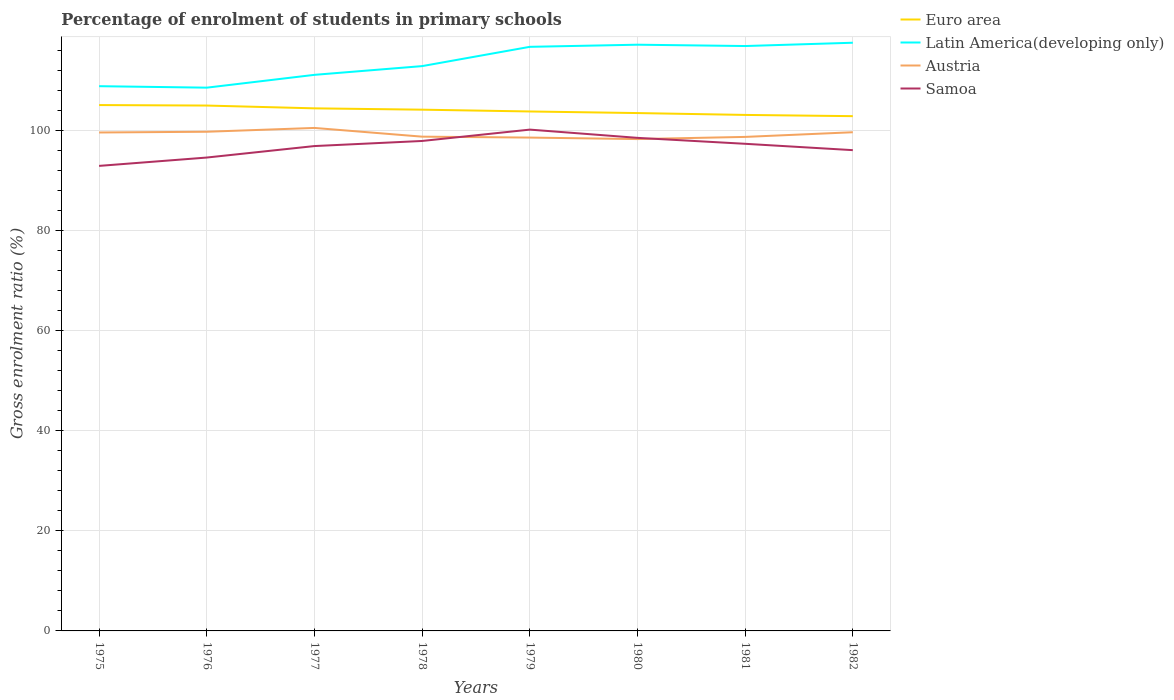Across all years, what is the maximum percentage of students enrolled in primary schools in Samoa?
Your answer should be compact. 92.93. In which year was the percentage of students enrolled in primary schools in Samoa maximum?
Ensure brevity in your answer.  1975. What is the total percentage of students enrolled in primary schools in Austria in the graph?
Ensure brevity in your answer.  0.98. What is the difference between the highest and the second highest percentage of students enrolled in primary schools in Latin America(developing only)?
Give a very brief answer. 8.98. Is the percentage of students enrolled in primary schools in Euro area strictly greater than the percentage of students enrolled in primary schools in Latin America(developing only) over the years?
Keep it short and to the point. Yes. How many lines are there?
Make the answer very short. 4. How many years are there in the graph?
Make the answer very short. 8. Does the graph contain any zero values?
Your response must be concise. No. How many legend labels are there?
Give a very brief answer. 4. How are the legend labels stacked?
Provide a short and direct response. Vertical. What is the title of the graph?
Ensure brevity in your answer.  Percentage of enrolment of students in primary schools. Does "Zimbabwe" appear as one of the legend labels in the graph?
Ensure brevity in your answer.  No. What is the label or title of the Y-axis?
Give a very brief answer. Gross enrolment ratio (%). What is the Gross enrolment ratio (%) in Euro area in 1975?
Provide a short and direct response. 105.08. What is the Gross enrolment ratio (%) of Latin America(developing only) in 1975?
Keep it short and to the point. 108.86. What is the Gross enrolment ratio (%) in Austria in 1975?
Provide a short and direct response. 99.6. What is the Gross enrolment ratio (%) of Samoa in 1975?
Provide a short and direct response. 92.93. What is the Gross enrolment ratio (%) of Euro area in 1976?
Your answer should be compact. 104.99. What is the Gross enrolment ratio (%) in Latin America(developing only) in 1976?
Provide a short and direct response. 108.56. What is the Gross enrolment ratio (%) of Austria in 1976?
Your response must be concise. 99.75. What is the Gross enrolment ratio (%) in Samoa in 1976?
Provide a short and direct response. 94.6. What is the Gross enrolment ratio (%) in Euro area in 1977?
Provide a short and direct response. 104.43. What is the Gross enrolment ratio (%) of Latin America(developing only) in 1977?
Offer a terse response. 111.12. What is the Gross enrolment ratio (%) of Austria in 1977?
Your response must be concise. 100.51. What is the Gross enrolment ratio (%) of Samoa in 1977?
Make the answer very short. 96.89. What is the Gross enrolment ratio (%) of Euro area in 1978?
Offer a very short reply. 104.16. What is the Gross enrolment ratio (%) of Latin America(developing only) in 1978?
Your response must be concise. 112.87. What is the Gross enrolment ratio (%) of Austria in 1978?
Offer a very short reply. 98.77. What is the Gross enrolment ratio (%) in Samoa in 1978?
Ensure brevity in your answer.  97.91. What is the Gross enrolment ratio (%) in Euro area in 1979?
Make the answer very short. 103.8. What is the Gross enrolment ratio (%) in Latin America(developing only) in 1979?
Give a very brief answer. 116.72. What is the Gross enrolment ratio (%) in Austria in 1979?
Your response must be concise. 98.59. What is the Gross enrolment ratio (%) in Samoa in 1979?
Offer a terse response. 100.18. What is the Gross enrolment ratio (%) in Euro area in 1980?
Your answer should be very brief. 103.49. What is the Gross enrolment ratio (%) of Latin America(developing only) in 1980?
Your answer should be very brief. 117.15. What is the Gross enrolment ratio (%) of Austria in 1980?
Your answer should be very brief. 98.29. What is the Gross enrolment ratio (%) in Samoa in 1980?
Provide a short and direct response. 98.53. What is the Gross enrolment ratio (%) in Euro area in 1981?
Your response must be concise. 103.12. What is the Gross enrolment ratio (%) of Latin America(developing only) in 1981?
Provide a succinct answer. 116.88. What is the Gross enrolment ratio (%) of Austria in 1981?
Ensure brevity in your answer.  98.72. What is the Gross enrolment ratio (%) in Samoa in 1981?
Make the answer very short. 97.34. What is the Gross enrolment ratio (%) in Euro area in 1982?
Keep it short and to the point. 102.87. What is the Gross enrolment ratio (%) of Latin America(developing only) in 1982?
Give a very brief answer. 117.54. What is the Gross enrolment ratio (%) of Austria in 1982?
Your answer should be very brief. 99.66. What is the Gross enrolment ratio (%) in Samoa in 1982?
Your response must be concise. 96.07. Across all years, what is the maximum Gross enrolment ratio (%) of Euro area?
Provide a succinct answer. 105.08. Across all years, what is the maximum Gross enrolment ratio (%) of Latin America(developing only)?
Provide a succinct answer. 117.54. Across all years, what is the maximum Gross enrolment ratio (%) of Austria?
Make the answer very short. 100.51. Across all years, what is the maximum Gross enrolment ratio (%) in Samoa?
Keep it short and to the point. 100.18. Across all years, what is the minimum Gross enrolment ratio (%) in Euro area?
Provide a succinct answer. 102.87. Across all years, what is the minimum Gross enrolment ratio (%) of Latin America(developing only)?
Keep it short and to the point. 108.56. Across all years, what is the minimum Gross enrolment ratio (%) of Austria?
Offer a terse response. 98.29. Across all years, what is the minimum Gross enrolment ratio (%) of Samoa?
Your response must be concise. 92.93. What is the total Gross enrolment ratio (%) of Euro area in the graph?
Your answer should be very brief. 831.93. What is the total Gross enrolment ratio (%) of Latin America(developing only) in the graph?
Give a very brief answer. 909.7. What is the total Gross enrolment ratio (%) in Austria in the graph?
Your answer should be very brief. 793.89. What is the total Gross enrolment ratio (%) in Samoa in the graph?
Your response must be concise. 774.46. What is the difference between the Gross enrolment ratio (%) in Euro area in 1975 and that in 1976?
Give a very brief answer. 0.1. What is the difference between the Gross enrolment ratio (%) in Latin America(developing only) in 1975 and that in 1976?
Provide a short and direct response. 0.29. What is the difference between the Gross enrolment ratio (%) in Austria in 1975 and that in 1976?
Your response must be concise. -0.15. What is the difference between the Gross enrolment ratio (%) in Samoa in 1975 and that in 1976?
Offer a terse response. -1.67. What is the difference between the Gross enrolment ratio (%) in Euro area in 1975 and that in 1977?
Make the answer very short. 0.66. What is the difference between the Gross enrolment ratio (%) of Latin America(developing only) in 1975 and that in 1977?
Your answer should be compact. -2.27. What is the difference between the Gross enrolment ratio (%) in Austria in 1975 and that in 1977?
Provide a succinct answer. -0.91. What is the difference between the Gross enrolment ratio (%) in Samoa in 1975 and that in 1977?
Keep it short and to the point. -3.96. What is the difference between the Gross enrolment ratio (%) of Euro area in 1975 and that in 1978?
Offer a terse response. 0.92. What is the difference between the Gross enrolment ratio (%) in Latin America(developing only) in 1975 and that in 1978?
Offer a terse response. -4.01. What is the difference between the Gross enrolment ratio (%) in Austria in 1975 and that in 1978?
Your response must be concise. 0.83. What is the difference between the Gross enrolment ratio (%) in Samoa in 1975 and that in 1978?
Make the answer very short. -4.98. What is the difference between the Gross enrolment ratio (%) of Euro area in 1975 and that in 1979?
Give a very brief answer. 1.28. What is the difference between the Gross enrolment ratio (%) of Latin America(developing only) in 1975 and that in 1979?
Make the answer very short. -7.86. What is the difference between the Gross enrolment ratio (%) in Austria in 1975 and that in 1979?
Your response must be concise. 1.02. What is the difference between the Gross enrolment ratio (%) of Samoa in 1975 and that in 1979?
Provide a short and direct response. -7.25. What is the difference between the Gross enrolment ratio (%) of Euro area in 1975 and that in 1980?
Offer a very short reply. 1.6. What is the difference between the Gross enrolment ratio (%) in Latin America(developing only) in 1975 and that in 1980?
Ensure brevity in your answer.  -8.29. What is the difference between the Gross enrolment ratio (%) of Austria in 1975 and that in 1980?
Ensure brevity in your answer.  1.32. What is the difference between the Gross enrolment ratio (%) in Samoa in 1975 and that in 1980?
Ensure brevity in your answer.  -5.6. What is the difference between the Gross enrolment ratio (%) of Euro area in 1975 and that in 1981?
Provide a short and direct response. 1.97. What is the difference between the Gross enrolment ratio (%) in Latin America(developing only) in 1975 and that in 1981?
Make the answer very short. -8.02. What is the difference between the Gross enrolment ratio (%) of Austria in 1975 and that in 1981?
Provide a succinct answer. 0.88. What is the difference between the Gross enrolment ratio (%) in Samoa in 1975 and that in 1981?
Your answer should be compact. -4.42. What is the difference between the Gross enrolment ratio (%) of Euro area in 1975 and that in 1982?
Provide a succinct answer. 2.22. What is the difference between the Gross enrolment ratio (%) in Latin America(developing only) in 1975 and that in 1982?
Ensure brevity in your answer.  -8.68. What is the difference between the Gross enrolment ratio (%) in Austria in 1975 and that in 1982?
Your answer should be very brief. -0.05. What is the difference between the Gross enrolment ratio (%) of Samoa in 1975 and that in 1982?
Your response must be concise. -3.15. What is the difference between the Gross enrolment ratio (%) of Euro area in 1976 and that in 1977?
Make the answer very short. 0.56. What is the difference between the Gross enrolment ratio (%) of Latin America(developing only) in 1976 and that in 1977?
Provide a succinct answer. -2.56. What is the difference between the Gross enrolment ratio (%) of Austria in 1976 and that in 1977?
Offer a terse response. -0.76. What is the difference between the Gross enrolment ratio (%) in Samoa in 1976 and that in 1977?
Give a very brief answer. -2.29. What is the difference between the Gross enrolment ratio (%) in Euro area in 1976 and that in 1978?
Ensure brevity in your answer.  0.82. What is the difference between the Gross enrolment ratio (%) of Latin America(developing only) in 1976 and that in 1978?
Provide a short and direct response. -4.31. What is the difference between the Gross enrolment ratio (%) in Austria in 1976 and that in 1978?
Provide a succinct answer. 0.98. What is the difference between the Gross enrolment ratio (%) of Samoa in 1976 and that in 1978?
Your response must be concise. -3.31. What is the difference between the Gross enrolment ratio (%) in Euro area in 1976 and that in 1979?
Provide a short and direct response. 1.18. What is the difference between the Gross enrolment ratio (%) of Latin America(developing only) in 1976 and that in 1979?
Keep it short and to the point. -8.16. What is the difference between the Gross enrolment ratio (%) of Austria in 1976 and that in 1979?
Ensure brevity in your answer.  1.16. What is the difference between the Gross enrolment ratio (%) in Samoa in 1976 and that in 1979?
Provide a succinct answer. -5.58. What is the difference between the Gross enrolment ratio (%) of Euro area in 1976 and that in 1980?
Your response must be concise. 1.5. What is the difference between the Gross enrolment ratio (%) of Latin America(developing only) in 1976 and that in 1980?
Keep it short and to the point. -8.58. What is the difference between the Gross enrolment ratio (%) in Austria in 1976 and that in 1980?
Give a very brief answer. 1.46. What is the difference between the Gross enrolment ratio (%) in Samoa in 1976 and that in 1980?
Ensure brevity in your answer.  -3.94. What is the difference between the Gross enrolment ratio (%) in Euro area in 1976 and that in 1981?
Your answer should be compact. 1.87. What is the difference between the Gross enrolment ratio (%) of Latin America(developing only) in 1976 and that in 1981?
Offer a terse response. -8.32. What is the difference between the Gross enrolment ratio (%) of Austria in 1976 and that in 1981?
Keep it short and to the point. 1.03. What is the difference between the Gross enrolment ratio (%) of Samoa in 1976 and that in 1981?
Offer a terse response. -2.75. What is the difference between the Gross enrolment ratio (%) in Euro area in 1976 and that in 1982?
Your answer should be very brief. 2.12. What is the difference between the Gross enrolment ratio (%) in Latin America(developing only) in 1976 and that in 1982?
Offer a very short reply. -8.98. What is the difference between the Gross enrolment ratio (%) of Austria in 1976 and that in 1982?
Offer a very short reply. 0.1. What is the difference between the Gross enrolment ratio (%) of Samoa in 1976 and that in 1982?
Your answer should be very brief. -1.48. What is the difference between the Gross enrolment ratio (%) of Euro area in 1977 and that in 1978?
Make the answer very short. 0.27. What is the difference between the Gross enrolment ratio (%) of Latin America(developing only) in 1977 and that in 1978?
Your response must be concise. -1.75. What is the difference between the Gross enrolment ratio (%) of Austria in 1977 and that in 1978?
Provide a short and direct response. 1.74. What is the difference between the Gross enrolment ratio (%) in Samoa in 1977 and that in 1978?
Ensure brevity in your answer.  -1.02. What is the difference between the Gross enrolment ratio (%) of Euro area in 1977 and that in 1979?
Provide a succinct answer. 0.62. What is the difference between the Gross enrolment ratio (%) of Latin America(developing only) in 1977 and that in 1979?
Your response must be concise. -5.6. What is the difference between the Gross enrolment ratio (%) in Austria in 1977 and that in 1979?
Your answer should be compact. 1.93. What is the difference between the Gross enrolment ratio (%) of Samoa in 1977 and that in 1979?
Your response must be concise. -3.29. What is the difference between the Gross enrolment ratio (%) of Euro area in 1977 and that in 1980?
Your response must be concise. 0.94. What is the difference between the Gross enrolment ratio (%) of Latin America(developing only) in 1977 and that in 1980?
Provide a short and direct response. -6.02. What is the difference between the Gross enrolment ratio (%) in Austria in 1977 and that in 1980?
Keep it short and to the point. 2.23. What is the difference between the Gross enrolment ratio (%) of Samoa in 1977 and that in 1980?
Ensure brevity in your answer.  -1.64. What is the difference between the Gross enrolment ratio (%) in Euro area in 1977 and that in 1981?
Your response must be concise. 1.31. What is the difference between the Gross enrolment ratio (%) of Latin America(developing only) in 1977 and that in 1981?
Offer a very short reply. -5.76. What is the difference between the Gross enrolment ratio (%) of Austria in 1977 and that in 1981?
Keep it short and to the point. 1.79. What is the difference between the Gross enrolment ratio (%) in Samoa in 1977 and that in 1981?
Offer a very short reply. -0.45. What is the difference between the Gross enrolment ratio (%) of Euro area in 1977 and that in 1982?
Your answer should be compact. 1.56. What is the difference between the Gross enrolment ratio (%) in Latin America(developing only) in 1977 and that in 1982?
Your answer should be compact. -6.42. What is the difference between the Gross enrolment ratio (%) in Austria in 1977 and that in 1982?
Your answer should be very brief. 0.86. What is the difference between the Gross enrolment ratio (%) in Samoa in 1977 and that in 1982?
Give a very brief answer. 0.82. What is the difference between the Gross enrolment ratio (%) of Euro area in 1978 and that in 1979?
Provide a succinct answer. 0.36. What is the difference between the Gross enrolment ratio (%) of Latin America(developing only) in 1978 and that in 1979?
Keep it short and to the point. -3.85. What is the difference between the Gross enrolment ratio (%) in Austria in 1978 and that in 1979?
Make the answer very short. 0.18. What is the difference between the Gross enrolment ratio (%) of Samoa in 1978 and that in 1979?
Ensure brevity in your answer.  -2.27. What is the difference between the Gross enrolment ratio (%) of Euro area in 1978 and that in 1980?
Your response must be concise. 0.68. What is the difference between the Gross enrolment ratio (%) in Latin America(developing only) in 1978 and that in 1980?
Provide a succinct answer. -4.28. What is the difference between the Gross enrolment ratio (%) of Austria in 1978 and that in 1980?
Offer a terse response. 0.48. What is the difference between the Gross enrolment ratio (%) in Samoa in 1978 and that in 1980?
Your response must be concise. -0.62. What is the difference between the Gross enrolment ratio (%) in Euro area in 1978 and that in 1981?
Make the answer very short. 1.05. What is the difference between the Gross enrolment ratio (%) of Latin America(developing only) in 1978 and that in 1981?
Ensure brevity in your answer.  -4.01. What is the difference between the Gross enrolment ratio (%) of Austria in 1978 and that in 1981?
Provide a succinct answer. 0.05. What is the difference between the Gross enrolment ratio (%) of Samoa in 1978 and that in 1981?
Give a very brief answer. 0.57. What is the difference between the Gross enrolment ratio (%) of Euro area in 1978 and that in 1982?
Make the answer very short. 1.3. What is the difference between the Gross enrolment ratio (%) in Latin America(developing only) in 1978 and that in 1982?
Give a very brief answer. -4.67. What is the difference between the Gross enrolment ratio (%) in Austria in 1978 and that in 1982?
Offer a very short reply. -0.88. What is the difference between the Gross enrolment ratio (%) in Samoa in 1978 and that in 1982?
Keep it short and to the point. 1.84. What is the difference between the Gross enrolment ratio (%) of Euro area in 1979 and that in 1980?
Your response must be concise. 0.32. What is the difference between the Gross enrolment ratio (%) of Latin America(developing only) in 1979 and that in 1980?
Provide a succinct answer. -0.42. What is the difference between the Gross enrolment ratio (%) of Austria in 1979 and that in 1980?
Offer a terse response. 0.3. What is the difference between the Gross enrolment ratio (%) in Samoa in 1979 and that in 1980?
Make the answer very short. 1.65. What is the difference between the Gross enrolment ratio (%) of Euro area in 1979 and that in 1981?
Offer a terse response. 0.69. What is the difference between the Gross enrolment ratio (%) of Latin America(developing only) in 1979 and that in 1981?
Offer a terse response. -0.16. What is the difference between the Gross enrolment ratio (%) in Austria in 1979 and that in 1981?
Keep it short and to the point. -0.13. What is the difference between the Gross enrolment ratio (%) in Samoa in 1979 and that in 1981?
Make the answer very short. 2.83. What is the difference between the Gross enrolment ratio (%) of Euro area in 1979 and that in 1982?
Provide a short and direct response. 0.94. What is the difference between the Gross enrolment ratio (%) of Latin America(developing only) in 1979 and that in 1982?
Offer a very short reply. -0.82. What is the difference between the Gross enrolment ratio (%) of Austria in 1979 and that in 1982?
Ensure brevity in your answer.  -1.07. What is the difference between the Gross enrolment ratio (%) of Samoa in 1979 and that in 1982?
Your answer should be very brief. 4.1. What is the difference between the Gross enrolment ratio (%) of Euro area in 1980 and that in 1981?
Make the answer very short. 0.37. What is the difference between the Gross enrolment ratio (%) in Latin America(developing only) in 1980 and that in 1981?
Provide a short and direct response. 0.27. What is the difference between the Gross enrolment ratio (%) of Austria in 1980 and that in 1981?
Your answer should be very brief. -0.43. What is the difference between the Gross enrolment ratio (%) of Samoa in 1980 and that in 1981?
Provide a succinct answer. 1.19. What is the difference between the Gross enrolment ratio (%) in Euro area in 1980 and that in 1982?
Make the answer very short. 0.62. What is the difference between the Gross enrolment ratio (%) of Latin America(developing only) in 1980 and that in 1982?
Provide a succinct answer. -0.39. What is the difference between the Gross enrolment ratio (%) in Austria in 1980 and that in 1982?
Offer a very short reply. -1.37. What is the difference between the Gross enrolment ratio (%) of Samoa in 1980 and that in 1982?
Offer a terse response. 2.46. What is the difference between the Gross enrolment ratio (%) of Euro area in 1981 and that in 1982?
Ensure brevity in your answer.  0.25. What is the difference between the Gross enrolment ratio (%) of Latin America(developing only) in 1981 and that in 1982?
Make the answer very short. -0.66. What is the difference between the Gross enrolment ratio (%) of Austria in 1981 and that in 1982?
Provide a short and direct response. -0.93. What is the difference between the Gross enrolment ratio (%) in Samoa in 1981 and that in 1982?
Your answer should be compact. 1.27. What is the difference between the Gross enrolment ratio (%) of Euro area in 1975 and the Gross enrolment ratio (%) of Latin America(developing only) in 1976?
Ensure brevity in your answer.  -3.48. What is the difference between the Gross enrolment ratio (%) of Euro area in 1975 and the Gross enrolment ratio (%) of Austria in 1976?
Your response must be concise. 5.33. What is the difference between the Gross enrolment ratio (%) of Euro area in 1975 and the Gross enrolment ratio (%) of Samoa in 1976?
Your answer should be compact. 10.49. What is the difference between the Gross enrolment ratio (%) in Latin America(developing only) in 1975 and the Gross enrolment ratio (%) in Austria in 1976?
Offer a terse response. 9.1. What is the difference between the Gross enrolment ratio (%) of Latin America(developing only) in 1975 and the Gross enrolment ratio (%) of Samoa in 1976?
Ensure brevity in your answer.  14.26. What is the difference between the Gross enrolment ratio (%) in Austria in 1975 and the Gross enrolment ratio (%) in Samoa in 1976?
Your response must be concise. 5.01. What is the difference between the Gross enrolment ratio (%) of Euro area in 1975 and the Gross enrolment ratio (%) of Latin America(developing only) in 1977?
Your answer should be very brief. -6.04. What is the difference between the Gross enrolment ratio (%) of Euro area in 1975 and the Gross enrolment ratio (%) of Austria in 1977?
Provide a short and direct response. 4.57. What is the difference between the Gross enrolment ratio (%) of Euro area in 1975 and the Gross enrolment ratio (%) of Samoa in 1977?
Your answer should be very brief. 8.19. What is the difference between the Gross enrolment ratio (%) of Latin America(developing only) in 1975 and the Gross enrolment ratio (%) of Austria in 1977?
Ensure brevity in your answer.  8.34. What is the difference between the Gross enrolment ratio (%) of Latin America(developing only) in 1975 and the Gross enrolment ratio (%) of Samoa in 1977?
Your answer should be very brief. 11.97. What is the difference between the Gross enrolment ratio (%) of Austria in 1975 and the Gross enrolment ratio (%) of Samoa in 1977?
Your answer should be compact. 2.71. What is the difference between the Gross enrolment ratio (%) in Euro area in 1975 and the Gross enrolment ratio (%) in Latin America(developing only) in 1978?
Provide a succinct answer. -7.78. What is the difference between the Gross enrolment ratio (%) of Euro area in 1975 and the Gross enrolment ratio (%) of Austria in 1978?
Your answer should be very brief. 6.31. What is the difference between the Gross enrolment ratio (%) of Euro area in 1975 and the Gross enrolment ratio (%) of Samoa in 1978?
Ensure brevity in your answer.  7.17. What is the difference between the Gross enrolment ratio (%) of Latin America(developing only) in 1975 and the Gross enrolment ratio (%) of Austria in 1978?
Offer a very short reply. 10.09. What is the difference between the Gross enrolment ratio (%) in Latin America(developing only) in 1975 and the Gross enrolment ratio (%) in Samoa in 1978?
Offer a terse response. 10.95. What is the difference between the Gross enrolment ratio (%) in Austria in 1975 and the Gross enrolment ratio (%) in Samoa in 1978?
Your response must be concise. 1.69. What is the difference between the Gross enrolment ratio (%) of Euro area in 1975 and the Gross enrolment ratio (%) of Latin America(developing only) in 1979?
Offer a terse response. -11.64. What is the difference between the Gross enrolment ratio (%) in Euro area in 1975 and the Gross enrolment ratio (%) in Austria in 1979?
Your answer should be compact. 6.5. What is the difference between the Gross enrolment ratio (%) of Euro area in 1975 and the Gross enrolment ratio (%) of Samoa in 1979?
Give a very brief answer. 4.91. What is the difference between the Gross enrolment ratio (%) in Latin America(developing only) in 1975 and the Gross enrolment ratio (%) in Austria in 1979?
Ensure brevity in your answer.  10.27. What is the difference between the Gross enrolment ratio (%) in Latin America(developing only) in 1975 and the Gross enrolment ratio (%) in Samoa in 1979?
Give a very brief answer. 8.68. What is the difference between the Gross enrolment ratio (%) of Austria in 1975 and the Gross enrolment ratio (%) of Samoa in 1979?
Give a very brief answer. -0.57. What is the difference between the Gross enrolment ratio (%) of Euro area in 1975 and the Gross enrolment ratio (%) of Latin America(developing only) in 1980?
Offer a very short reply. -12.06. What is the difference between the Gross enrolment ratio (%) of Euro area in 1975 and the Gross enrolment ratio (%) of Austria in 1980?
Your answer should be very brief. 6.8. What is the difference between the Gross enrolment ratio (%) of Euro area in 1975 and the Gross enrolment ratio (%) of Samoa in 1980?
Offer a terse response. 6.55. What is the difference between the Gross enrolment ratio (%) of Latin America(developing only) in 1975 and the Gross enrolment ratio (%) of Austria in 1980?
Your answer should be very brief. 10.57. What is the difference between the Gross enrolment ratio (%) in Latin America(developing only) in 1975 and the Gross enrolment ratio (%) in Samoa in 1980?
Provide a short and direct response. 10.32. What is the difference between the Gross enrolment ratio (%) of Austria in 1975 and the Gross enrolment ratio (%) of Samoa in 1980?
Provide a succinct answer. 1.07. What is the difference between the Gross enrolment ratio (%) in Euro area in 1975 and the Gross enrolment ratio (%) in Latin America(developing only) in 1981?
Offer a very short reply. -11.8. What is the difference between the Gross enrolment ratio (%) in Euro area in 1975 and the Gross enrolment ratio (%) in Austria in 1981?
Provide a succinct answer. 6.36. What is the difference between the Gross enrolment ratio (%) in Euro area in 1975 and the Gross enrolment ratio (%) in Samoa in 1981?
Your answer should be very brief. 7.74. What is the difference between the Gross enrolment ratio (%) of Latin America(developing only) in 1975 and the Gross enrolment ratio (%) of Austria in 1981?
Ensure brevity in your answer.  10.14. What is the difference between the Gross enrolment ratio (%) in Latin America(developing only) in 1975 and the Gross enrolment ratio (%) in Samoa in 1981?
Offer a terse response. 11.51. What is the difference between the Gross enrolment ratio (%) in Austria in 1975 and the Gross enrolment ratio (%) in Samoa in 1981?
Provide a succinct answer. 2.26. What is the difference between the Gross enrolment ratio (%) in Euro area in 1975 and the Gross enrolment ratio (%) in Latin America(developing only) in 1982?
Provide a short and direct response. -12.46. What is the difference between the Gross enrolment ratio (%) in Euro area in 1975 and the Gross enrolment ratio (%) in Austria in 1982?
Provide a short and direct response. 5.43. What is the difference between the Gross enrolment ratio (%) of Euro area in 1975 and the Gross enrolment ratio (%) of Samoa in 1982?
Offer a terse response. 9.01. What is the difference between the Gross enrolment ratio (%) of Latin America(developing only) in 1975 and the Gross enrolment ratio (%) of Austria in 1982?
Make the answer very short. 9.2. What is the difference between the Gross enrolment ratio (%) in Latin America(developing only) in 1975 and the Gross enrolment ratio (%) in Samoa in 1982?
Make the answer very short. 12.78. What is the difference between the Gross enrolment ratio (%) of Austria in 1975 and the Gross enrolment ratio (%) of Samoa in 1982?
Provide a short and direct response. 3.53. What is the difference between the Gross enrolment ratio (%) of Euro area in 1976 and the Gross enrolment ratio (%) of Latin America(developing only) in 1977?
Make the answer very short. -6.14. What is the difference between the Gross enrolment ratio (%) in Euro area in 1976 and the Gross enrolment ratio (%) in Austria in 1977?
Your answer should be compact. 4.47. What is the difference between the Gross enrolment ratio (%) of Euro area in 1976 and the Gross enrolment ratio (%) of Samoa in 1977?
Make the answer very short. 8.1. What is the difference between the Gross enrolment ratio (%) of Latin America(developing only) in 1976 and the Gross enrolment ratio (%) of Austria in 1977?
Ensure brevity in your answer.  8.05. What is the difference between the Gross enrolment ratio (%) in Latin America(developing only) in 1976 and the Gross enrolment ratio (%) in Samoa in 1977?
Your answer should be very brief. 11.67. What is the difference between the Gross enrolment ratio (%) in Austria in 1976 and the Gross enrolment ratio (%) in Samoa in 1977?
Give a very brief answer. 2.86. What is the difference between the Gross enrolment ratio (%) in Euro area in 1976 and the Gross enrolment ratio (%) in Latin America(developing only) in 1978?
Give a very brief answer. -7.88. What is the difference between the Gross enrolment ratio (%) in Euro area in 1976 and the Gross enrolment ratio (%) in Austria in 1978?
Provide a succinct answer. 6.22. What is the difference between the Gross enrolment ratio (%) of Euro area in 1976 and the Gross enrolment ratio (%) of Samoa in 1978?
Keep it short and to the point. 7.08. What is the difference between the Gross enrolment ratio (%) in Latin America(developing only) in 1976 and the Gross enrolment ratio (%) in Austria in 1978?
Provide a short and direct response. 9.79. What is the difference between the Gross enrolment ratio (%) of Latin America(developing only) in 1976 and the Gross enrolment ratio (%) of Samoa in 1978?
Provide a succinct answer. 10.65. What is the difference between the Gross enrolment ratio (%) in Austria in 1976 and the Gross enrolment ratio (%) in Samoa in 1978?
Provide a succinct answer. 1.84. What is the difference between the Gross enrolment ratio (%) in Euro area in 1976 and the Gross enrolment ratio (%) in Latin America(developing only) in 1979?
Your answer should be compact. -11.73. What is the difference between the Gross enrolment ratio (%) of Euro area in 1976 and the Gross enrolment ratio (%) of Austria in 1979?
Your answer should be compact. 6.4. What is the difference between the Gross enrolment ratio (%) of Euro area in 1976 and the Gross enrolment ratio (%) of Samoa in 1979?
Offer a very short reply. 4.81. What is the difference between the Gross enrolment ratio (%) of Latin America(developing only) in 1976 and the Gross enrolment ratio (%) of Austria in 1979?
Provide a succinct answer. 9.97. What is the difference between the Gross enrolment ratio (%) in Latin America(developing only) in 1976 and the Gross enrolment ratio (%) in Samoa in 1979?
Ensure brevity in your answer.  8.38. What is the difference between the Gross enrolment ratio (%) in Austria in 1976 and the Gross enrolment ratio (%) in Samoa in 1979?
Keep it short and to the point. -0.43. What is the difference between the Gross enrolment ratio (%) in Euro area in 1976 and the Gross enrolment ratio (%) in Latin America(developing only) in 1980?
Keep it short and to the point. -12.16. What is the difference between the Gross enrolment ratio (%) in Euro area in 1976 and the Gross enrolment ratio (%) in Austria in 1980?
Provide a short and direct response. 6.7. What is the difference between the Gross enrolment ratio (%) of Euro area in 1976 and the Gross enrolment ratio (%) of Samoa in 1980?
Keep it short and to the point. 6.46. What is the difference between the Gross enrolment ratio (%) in Latin America(developing only) in 1976 and the Gross enrolment ratio (%) in Austria in 1980?
Give a very brief answer. 10.28. What is the difference between the Gross enrolment ratio (%) in Latin America(developing only) in 1976 and the Gross enrolment ratio (%) in Samoa in 1980?
Give a very brief answer. 10.03. What is the difference between the Gross enrolment ratio (%) in Austria in 1976 and the Gross enrolment ratio (%) in Samoa in 1980?
Offer a terse response. 1.22. What is the difference between the Gross enrolment ratio (%) in Euro area in 1976 and the Gross enrolment ratio (%) in Latin America(developing only) in 1981?
Make the answer very short. -11.89. What is the difference between the Gross enrolment ratio (%) in Euro area in 1976 and the Gross enrolment ratio (%) in Austria in 1981?
Offer a very short reply. 6.27. What is the difference between the Gross enrolment ratio (%) of Euro area in 1976 and the Gross enrolment ratio (%) of Samoa in 1981?
Provide a short and direct response. 7.64. What is the difference between the Gross enrolment ratio (%) in Latin America(developing only) in 1976 and the Gross enrolment ratio (%) in Austria in 1981?
Ensure brevity in your answer.  9.84. What is the difference between the Gross enrolment ratio (%) in Latin America(developing only) in 1976 and the Gross enrolment ratio (%) in Samoa in 1981?
Give a very brief answer. 11.22. What is the difference between the Gross enrolment ratio (%) of Austria in 1976 and the Gross enrolment ratio (%) of Samoa in 1981?
Ensure brevity in your answer.  2.41. What is the difference between the Gross enrolment ratio (%) of Euro area in 1976 and the Gross enrolment ratio (%) of Latin America(developing only) in 1982?
Ensure brevity in your answer.  -12.55. What is the difference between the Gross enrolment ratio (%) in Euro area in 1976 and the Gross enrolment ratio (%) in Austria in 1982?
Provide a short and direct response. 5.33. What is the difference between the Gross enrolment ratio (%) of Euro area in 1976 and the Gross enrolment ratio (%) of Samoa in 1982?
Ensure brevity in your answer.  8.91. What is the difference between the Gross enrolment ratio (%) in Latin America(developing only) in 1976 and the Gross enrolment ratio (%) in Austria in 1982?
Offer a terse response. 8.91. What is the difference between the Gross enrolment ratio (%) of Latin America(developing only) in 1976 and the Gross enrolment ratio (%) of Samoa in 1982?
Your answer should be very brief. 12.49. What is the difference between the Gross enrolment ratio (%) of Austria in 1976 and the Gross enrolment ratio (%) of Samoa in 1982?
Offer a terse response. 3.68. What is the difference between the Gross enrolment ratio (%) of Euro area in 1977 and the Gross enrolment ratio (%) of Latin America(developing only) in 1978?
Your response must be concise. -8.44. What is the difference between the Gross enrolment ratio (%) of Euro area in 1977 and the Gross enrolment ratio (%) of Austria in 1978?
Your answer should be compact. 5.66. What is the difference between the Gross enrolment ratio (%) in Euro area in 1977 and the Gross enrolment ratio (%) in Samoa in 1978?
Keep it short and to the point. 6.52. What is the difference between the Gross enrolment ratio (%) in Latin America(developing only) in 1977 and the Gross enrolment ratio (%) in Austria in 1978?
Keep it short and to the point. 12.35. What is the difference between the Gross enrolment ratio (%) in Latin America(developing only) in 1977 and the Gross enrolment ratio (%) in Samoa in 1978?
Give a very brief answer. 13.21. What is the difference between the Gross enrolment ratio (%) in Austria in 1977 and the Gross enrolment ratio (%) in Samoa in 1978?
Give a very brief answer. 2.6. What is the difference between the Gross enrolment ratio (%) in Euro area in 1977 and the Gross enrolment ratio (%) in Latin America(developing only) in 1979?
Ensure brevity in your answer.  -12.29. What is the difference between the Gross enrolment ratio (%) in Euro area in 1977 and the Gross enrolment ratio (%) in Austria in 1979?
Ensure brevity in your answer.  5.84. What is the difference between the Gross enrolment ratio (%) in Euro area in 1977 and the Gross enrolment ratio (%) in Samoa in 1979?
Your answer should be very brief. 4.25. What is the difference between the Gross enrolment ratio (%) in Latin America(developing only) in 1977 and the Gross enrolment ratio (%) in Austria in 1979?
Make the answer very short. 12.53. What is the difference between the Gross enrolment ratio (%) in Latin America(developing only) in 1977 and the Gross enrolment ratio (%) in Samoa in 1979?
Your response must be concise. 10.94. What is the difference between the Gross enrolment ratio (%) of Austria in 1977 and the Gross enrolment ratio (%) of Samoa in 1979?
Your answer should be compact. 0.34. What is the difference between the Gross enrolment ratio (%) of Euro area in 1977 and the Gross enrolment ratio (%) of Latin America(developing only) in 1980?
Provide a short and direct response. -12.72. What is the difference between the Gross enrolment ratio (%) in Euro area in 1977 and the Gross enrolment ratio (%) in Austria in 1980?
Make the answer very short. 6.14. What is the difference between the Gross enrolment ratio (%) of Euro area in 1977 and the Gross enrolment ratio (%) of Samoa in 1980?
Your answer should be very brief. 5.9. What is the difference between the Gross enrolment ratio (%) of Latin America(developing only) in 1977 and the Gross enrolment ratio (%) of Austria in 1980?
Your answer should be compact. 12.84. What is the difference between the Gross enrolment ratio (%) in Latin America(developing only) in 1977 and the Gross enrolment ratio (%) in Samoa in 1980?
Ensure brevity in your answer.  12.59. What is the difference between the Gross enrolment ratio (%) in Austria in 1977 and the Gross enrolment ratio (%) in Samoa in 1980?
Give a very brief answer. 1.98. What is the difference between the Gross enrolment ratio (%) in Euro area in 1977 and the Gross enrolment ratio (%) in Latin America(developing only) in 1981?
Give a very brief answer. -12.45. What is the difference between the Gross enrolment ratio (%) of Euro area in 1977 and the Gross enrolment ratio (%) of Austria in 1981?
Your answer should be very brief. 5.71. What is the difference between the Gross enrolment ratio (%) of Euro area in 1977 and the Gross enrolment ratio (%) of Samoa in 1981?
Keep it short and to the point. 7.08. What is the difference between the Gross enrolment ratio (%) of Latin America(developing only) in 1977 and the Gross enrolment ratio (%) of Austria in 1981?
Provide a succinct answer. 12.4. What is the difference between the Gross enrolment ratio (%) in Latin America(developing only) in 1977 and the Gross enrolment ratio (%) in Samoa in 1981?
Your answer should be compact. 13.78. What is the difference between the Gross enrolment ratio (%) in Austria in 1977 and the Gross enrolment ratio (%) in Samoa in 1981?
Ensure brevity in your answer.  3.17. What is the difference between the Gross enrolment ratio (%) of Euro area in 1977 and the Gross enrolment ratio (%) of Latin America(developing only) in 1982?
Ensure brevity in your answer.  -13.11. What is the difference between the Gross enrolment ratio (%) of Euro area in 1977 and the Gross enrolment ratio (%) of Austria in 1982?
Provide a succinct answer. 4.77. What is the difference between the Gross enrolment ratio (%) of Euro area in 1977 and the Gross enrolment ratio (%) of Samoa in 1982?
Provide a succinct answer. 8.35. What is the difference between the Gross enrolment ratio (%) in Latin America(developing only) in 1977 and the Gross enrolment ratio (%) in Austria in 1982?
Ensure brevity in your answer.  11.47. What is the difference between the Gross enrolment ratio (%) in Latin America(developing only) in 1977 and the Gross enrolment ratio (%) in Samoa in 1982?
Keep it short and to the point. 15.05. What is the difference between the Gross enrolment ratio (%) in Austria in 1977 and the Gross enrolment ratio (%) in Samoa in 1982?
Provide a succinct answer. 4.44. What is the difference between the Gross enrolment ratio (%) in Euro area in 1978 and the Gross enrolment ratio (%) in Latin America(developing only) in 1979?
Your answer should be very brief. -12.56. What is the difference between the Gross enrolment ratio (%) of Euro area in 1978 and the Gross enrolment ratio (%) of Austria in 1979?
Keep it short and to the point. 5.57. What is the difference between the Gross enrolment ratio (%) of Euro area in 1978 and the Gross enrolment ratio (%) of Samoa in 1979?
Your answer should be very brief. 3.98. What is the difference between the Gross enrolment ratio (%) in Latin America(developing only) in 1978 and the Gross enrolment ratio (%) in Austria in 1979?
Ensure brevity in your answer.  14.28. What is the difference between the Gross enrolment ratio (%) in Latin America(developing only) in 1978 and the Gross enrolment ratio (%) in Samoa in 1979?
Offer a very short reply. 12.69. What is the difference between the Gross enrolment ratio (%) in Austria in 1978 and the Gross enrolment ratio (%) in Samoa in 1979?
Provide a short and direct response. -1.41. What is the difference between the Gross enrolment ratio (%) in Euro area in 1978 and the Gross enrolment ratio (%) in Latin America(developing only) in 1980?
Make the answer very short. -12.98. What is the difference between the Gross enrolment ratio (%) of Euro area in 1978 and the Gross enrolment ratio (%) of Austria in 1980?
Offer a terse response. 5.88. What is the difference between the Gross enrolment ratio (%) of Euro area in 1978 and the Gross enrolment ratio (%) of Samoa in 1980?
Ensure brevity in your answer.  5.63. What is the difference between the Gross enrolment ratio (%) of Latin America(developing only) in 1978 and the Gross enrolment ratio (%) of Austria in 1980?
Ensure brevity in your answer.  14.58. What is the difference between the Gross enrolment ratio (%) in Latin America(developing only) in 1978 and the Gross enrolment ratio (%) in Samoa in 1980?
Your answer should be compact. 14.34. What is the difference between the Gross enrolment ratio (%) of Austria in 1978 and the Gross enrolment ratio (%) of Samoa in 1980?
Your answer should be compact. 0.24. What is the difference between the Gross enrolment ratio (%) in Euro area in 1978 and the Gross enrolment ratio (%) in Latin America(developing only) in 1981?
Ensure brevity in your answer.  -12.72. What is the difference between the Gross enrolment ratio (%) in Euro area in 1978 and the Gross enrolment ratio (%) in Austria in 1981?
Provide a short and direct response. 5.44. What is the difference between the Gross enrolment ratio (%) in Euro area in 1978 and the Gross enrolment ratio (%) in Samoa in 1981?
Offer a terse response. 6.82. What is the difference between the Gross enrolment ratio (%) in Latin America(developing only) in 1978 and the Gross enrolment ratio (%) in Austria in 1981?
Make the answer very short. 14.15. What is the difference between the Gross enrolment ratio (%) of Latin America(developing only) in 1978 and the Gross enrolment ratio (%) of Samoa in 1981?
Your answer should be compact. 15.52. What is the difference between the Gross enrolment ratio (%) of Austria in 1978 and the Gross enrolment ratio (%) of Samoa in 1981?
Offer a very short reply. 1.43. What is the difference between the Gross enrolment ratio (%) in Euro area in 1978 and the Gross enrolment ratio (%) in Latin America(developing only) in 1982?
Provide a short and direct response. -13.38. What is the difference between the Gross enrolment ratio (%) of Euro area in 1978 and the Gross enrolment ratio (%) of Austria in 1982?
Offer a very short reply. 4.51. What is the difference between the Gross enrolment ratio (%) in Euro area in 1978 and the Gross enrolment ratio (%) in Samoa in 1982?
Offer a very short reply. 8.09. What is the difference between the Gross enrolment ratio (%) in Latin America(developing only) in 1978 and the Gross enrolment ratio (%) in Austria in 1982?
Give a very brief answer. 13.21. What is the difference between the Gross enrolment ratio (%) of Latin America(developing only) in 1978 and the Gross enrolment ratio (%) of Samoa in 1982?
Offer a very short reply. 16.79. What is the difference between the Gross enrolment ratio (%) in Austria in 1978 and the Gross enrolment ratio (%) in Samoa in 1982?
Your answer should be very brief. 2.7. What is the difference between the Gross enrolment ratio (%) in Euro area in 1979 and the Gross enrolment ratio (%) in Latin America(developing only) in 1980?
Your answer should be compact. -13.34. What is the difference between the Gross enrolment ratio (%) of Euro area in 1979 and the Gross enrolment ratio (%) of Austria in 1980?
Provide a succinct answer. 5.52. What is the difference between the Gross enrolment ratio (%) of Euro area in 1979 and the Gross enrolment ratio (%) of Samoa in 1980?
Your response must be concise. 5.27. What is the difference between the Gross enrolment ratio (%) of Latin America(developing only) in 1979 and the Gross enrolment ratio (%) of Austria in 1980?
Offer a very short reply. 18.43. What is the difference between the Gross enrolment ratio (%) of Latin America(developing only) in 1979 and the Gross enrolment ratio (%) of Samoa in 1980?
Your response must be concise. 18.19. What is the difference between the Gross enrolment ratio (%) of Austria in 1979 and the Gross enrolment ratio (%) of Samoa in 1980?
Ensure brevity in your answer.  0.06. What is the difference between the Gross enrolment ratio (%) in Euro area in 1979 and the Gross enrolment ratio (%) in Latin America(developing only) in 1981?
Offer a very short reply. -13.08. What is the difference between the Gross enrolment ratio (%) in Euro area in 1979 and the Gross enrolment ratio (%) in Austria in 1981?
Offer a terse response. 5.08. What is the difference between the Gross enrolment ratio (%) in Euro area in 1979 and the Gross enrolment ratio (%) in Samoa in 1981?
Your response must be concise. 6.46. What is the difference between the Gross enrolment ratio (%) of Latin America(developing only) in 1979 and the Gross enrolment ratio (%) of Austria in 1981?
Your response must be concise. 18. What is the difference between the Gross enrolment ratio (%) of Latin America(developing only) in 1979 and the Gross enrolment ratio (%) of Samoa in 1981?
Give a very brief answer. 19.38. What is the difference between the Gross enrolment ratio (%) of Austria in 1979 and the Gross enrolment ratio (%) of Samoa in 1981?
Your answer should be very brief. 1.24. What is the difference between the Gross enrolment ratio (%) in Euro area in 1979 and the Gross enrolment ratio (%) in Latin America(developing only) in 1982?
Give a very brief answer. -13.74. What is the difference between the Gross enrolment ratio (%) of Euro area in 1979 and the Gross enrolment ratio (%) of Austria in 1982?
Offer a terse response. 4.15. What is the difference between the Gross enrolment ratio (%) in Euro area in 1979 and the Gross enrolment ratio (%) in Samoa in 1982?
Give a very brief answer. 7.73. What is the difference between the Gross enrolment ratio (%) of Latin America(developing only) in 1979 and the Gross enrolment ratio (%) of Austria in 1982?
Provide a succinct answer. 17.07. What is the difference between the Gross enrolment ratio (%) in Latin America(developing only) in 1979 and the Gross enrolment ratio (%) in Samoa in 1982?
Ensure brevity in your answer.  20.65. What is the difference between the Gross enrolment ratio (%) of Austria in 1979 and the Gross enrolment ratio (%) of Samoa in 1982?
Provide a short and direct response. 2.51. What is the difference between the Gross enrolment ratio (%) of Euro area in 1980 and the Gross enrolment ratio (%) of Latin America(developing only) in 1981?
Give a very brief answer. -13.39. What is the difference between the Gross enrolment ratio (%) in Euro area in 1980 and the Gross enrolment ratio (%) in Austria in 1981?
Offer a terse response. 4.76. What is the difference between the Gross enrolment ratio (%) of Euro area in 1980 and the Gross enrolment ratio (%) of Samoa in 1981?
Your answer should be very brief. 6.14. What is the difference between the Gross enrolment ratio (%) in Latin America(developing only) in 1980 and the Gross enrolment ratio (%) in Austria in 1981?
Make the answer very short. 18.43. What is the difference between the Gross enrolment ratio (%) in Latin America(developing only) in 1980 and the Gross enrolment ratio (%) in Samoa in 1981?
Your response must be concise. 19.8. What is the difference between the Gross enrolment ratio (%) of Austria in 1980 and the Gross enrolment ratio (%) of Samoa in 1981?
Your answer should be compact. 0.94. What is the difference between the Gross enrolment ratio (%) of Euro area in 1980 and the Gross enrolment ratio (%) of Latin America(developing only) in 1982?
Provide a succinct answer. -14.05. What is the difference between the Gross enrolment ratio (%) of Euro area in 1980 and the Gross enrolment ratio (%) of Austria in 1982?
Your answer should be very brief. 3.83. What is the difference between the Gross enrolment ratio (%) in Euro area in 1980 and the Gross enrolment ratio (%) in Samoa in 1982?
Provide a short and direct response. 7.41. What is the difference between the Gross enrolment ratio (%) of Latin America(developing only) in 1980 and the Gross enrolment ratio (%) of Austria in 1982?
Offer a terse response. 17.49. What is the difference between the Gross enrolment ratio (%) in Latin America(developing only) in 1980 and the Gross enrolment ratio (%) in Samoa in 1982?
Offer a very short reply. 21.07. What is the difference between the Gross enrolment ratio (%) of Austria in 1980 and the Gross enrolment ratio (%) of Samoa in 1982?
Provide a succinct answer. 2.21. What is the difference between the Gross enrolment ratio (%) of Euro area in 1981 and the Gross enrolment ratio (%) of Latin America(developing only) in 1982?
Your answer should be compact. -14.42. What is the difference between the Gross enrolment ratio (%) in Euro area in 1981 and the Gross enrolment ratio (%) in Austria in 1982?
Offer a very short reply. 3.46. What is the difference between the Gross enrolment ratio (%) of Euro area in 1981 and the Gross enrolment ratio (%) of Samoa in 1982?
Your response must be concise. 7.04. What is the difference between the Gross enrolment ratio (%) of Latin America(developing only) in 1981 and the Gross enrolment ratio (%) of Austria in 1982?
Ensure brevity in your answer.  17.23. What is the difference between the Gross enrolment ratio (%) in Latin America(developing only) in 1981 and the Gross enrolment ratio (%) in Samoa in 1982?
Provide a succinct answer. 20.81. What is the difference between the Gross enrolment ratio (%) in Austria in 1981 and the Gross enrolment ratio (%) in Samoa in 1982?
Give a very brief answer. 2.65. What is the average Gross enrolment ratio (%) of Euro area per year?
Provide a succinct answer. 103.99. What is the average Gross enrolment ratio (%) in Latin America(developing only) per year?
Provide a succinct answer. 113.71. What is the average Gross enrolment ratio (%) in Austria per year?
Ensure brevity in your answer.  99.24. What is the average Gross enrolment ratio (%) in Samoa per year?
Provide a succinct answer. 96.81. In the year 1975, what is the difference between the Gross enrolment ratio (%) in Euro area and Gross enrolment ratio (%) in Latin America(developing only)?
Ensure brevity in your answer.  -3.77. In the year 1975, what is the difference between the Gross enrolment ratio (%) in Euro area and Gross enrolment ratio (%) in Austria?
Your response must be concise. 5.48. In the year 1975, what is the difference between the Gross enrolment ratio (%) in Euro area and Gross enrolment ratio (%) in Samoa?
Your response must be concise. 12.16. In the year 1975, what is the difference between the Gross enrolment ratio (%) of Latin America(developing only) and Gross enrolment ratio (%) of Austria?
Keep it short and to the point. 9.25. In the year 1975, what is the difference between the Gross enrolment ratio (%) of Latin America(developing only) and Gross enrolment ratio (%) of Samoa?
Provide a succinct answer. 15.93. In the year 1975, what is the difference between the Gross enrolment ratio (%) in Austria and Gross enrolment ratio (%) in Samoa?
Your response must be concise. 6.67. In the year 1976, what is the difference between the Gross enrolment ratio (%) in Euro area and Gross enrolment ratio (%) in Latin America(developing only)?
Your answer should be compact. -3.58. In the year 1976, what is the difference between the Gross enrolment ratio (%) of Euro area and Gross enrolment ratio (%) of Austria?
Ensure brevity in your answer.  5.24. In the year 1976, what is the difference between the Gross enrolment ratio (%) of Euro area and Gross enrolment ratio (%) of Samoa?
Keep it short and to the point. 10.39. In the year 1976, what is the difference between the Gross enrolment ratio (%) in Latin America(developing only) and Gross enrolment ratio (%) in Austria?
Provide a succinct answer. 8.81. In the year 1976, what is the difference between the Gross enrolment ratio (%) in Latin America(developing only) and Gross enrolment ratio (%) in Samoa?
Your answer should be compact. 13.97. In the year 1976, what is the difference between the Gross enrolment ratio (%) of Austria and Gross enrolment ratio (%) of Samoa?
Offer a terse response. 5.16. In the year 1977, what is the difference between the Gross enrolment ratio (%) of Euro area and Gross enrolment ratio (%) of Latin America(developing only)?
Your answer should be very brief. -6.69. In the year 1977, what is the difference between the Gross enrolment ratio (%) in Euro area and Gross enrolment ratio (%) in Austria?
Your answer should be very brief. 3.91. In the year 1977, what is the difference between the Gross enrolment ratio (%) of Euro area and Gross enrolment ratio (%) of Samoa?
Ensure brevity in your answer.  7.54. In the year 1977, what is the difference between the Gross enrolment ratio (%) in Latin America(developing only) and Gross enrolment ratio (%) in Austria?
Provide a succinct answer. 10.61. In the year 1977, what is the difference between the Gross enrolment ratio (%) in Latin America(developing only) and Gross enrolment ratio (%) in Samoa?
Offer a terse response. 14.23. In the year 1977, what is the difference between the Gross enrolment ratio (%) of Austria and Gross enrolment ratio (%) of Samoa?
Your answer should be very brief. 3.62. In the year 1978, what is the difference between the Gross enrolment ratio (%) of Euro area and Gross enrolment ratio (%) of Latin America(developing only)?
Provide a short and direct response. -8.71. In the year 1978, what is the difference between the Gross enrolment ratio (%) in Euro area and Gross enrolment ratio (%) in Austria?
Offer a terse response. 5.39. In the year 1978, what is the difference between the Gross enrolment ratio (%) in Euro area and Gross enrolment ratio (%) in Samoa?
Keep it short and to the point. 6.25. In the year 1978, what is the difference between the Gross enrolment ratio (%) in Latin America(developing only) and Gross enrolment ratio (%) in Austria?
Your answer should be compact. 14.1. In the year 1978, what is the difference between the Gross enrolment ratio (%) of Latin America(developing only) and Gross enrolment ratio (%) of Samoa?
Your answer should be compact. 14.96. In the year 1978, what is the difference between the Gross enrolment ratio (%) in Austria and Gross enrolment ratio (%) in Samoa?
Offer a very short reply. 0.86. In the year 1979, what is the difference between the Gross enrolment ratio (%) in Euro area and Gross enrolment ratio (%) in Latin America(developing only)?
Ensure brevity in your answer.  -12.92. In the year 1979, what is the difference between the Gross enrolment ratio (%) of Euro area and Gross enrolment ratio (%) of Austria?
Ensure brevity in your answer.  5.22. In the year 1979, what is the difference between the Gross enrolment ratio (%) of Euro area and Gross enrolment ratio (%) of Samoa?
Your answer should be compact. 3.62. In the year 1979, what is the difference between the Gross enrolment ratio (%) in Latin America(developing only) and Gross enrolment ratio (%) in Austria?
Your response must be concise. 18.13. In the year 1979, what is the difference between the Gross enrolment ratio (%) of Latin America(developing only) and Gross enrolment ratio (%) of Samoa?
Offer a very short reply. 16.54. In the year 1979, what is the difference between the Gross enrolment ratio (%) of Austria and Gross enrolment ratio (%) of Samoa?
Give a very brief answer. -1.59. In the year 1980, what is the difference between the Gross enrolment ratio (%) in Euro area and Gross enrolment ratio (%) in Latin America(developing only)?
Offer a terse response. -13.66. In the year 1980, what is the difference between the Gross enrolment ratio (%) of Euro area and Gross enrolment ratio (%) of Austria?
Make the answer very short. 5.2. In the year 1980, what is the difference between the Gross enrolment ratio (%) of Euro area and Gross enrolment ratio (%) of Samoa?
Your answer should be very brief. 4.95. In the year 1980, what is the difference between the Gross enrolment ratio (%) in Latin America(developing only) and Gross enrolment ratio (%) in Austria?
Provide a succinct answer. 18.86. In the year 1980, what is the difference between the Gross enrolment ratio (%) in Latin America(developing only) and Gross enrolment ratio (%) in Samoa?
Ensure brevity in your answer.  18.61. In the year 1980, what is the difference between the Gross enrolment ratio (%) of Austria and Gross enrolment ratio (%) of Samoa?
Your answer should be very brief. -0.24. In the year 1981, what is the difference between the Gross enrolment ratio (%) in Euro area and Gross enrolment ratio (%) in Latin America(developing only)?
Keep it short and to the point. -13.77. In the year 1981, what is the difference between the Gross enrolment ratio (%) of Euro area and Gross enrolment ratio (%) of Austria?
Ensure brevity in your answer.  4.39. In the year 1981, what is the difference between the Gross enrolment ratio (%) in Euro area and Gross enrolment ratio (%) in Samoa?
Make the answer very short. 5.77. In the year 1981, what is the difference between the Gross enrolment ratio (%) in Latin America(developing only) and Gross enrolment ratio (%) in Austria?
Your answer should be compact. 18.16. In the year 1981, what is the difference between the Gross enrolment ratio (%) of Latin America(developing only) and Gross enrolment ratio (%) of Samoa?
Keep it short and to the point. 19.54. In the year 1981, what is the difference between the Gross enrolment ratio (%) of Austria and Gross enrolment ratio (%) of Samoa?
Your answer should be very brief. 1.38. In the year 1982, what is the difference between the Gross enrolment ratio (%) in Euro area and Gross enrolment ratio (%) in Latin America(developing only)?
Your answer should be very brief. -14.67. In the year 1982, what is the difference between the Gross enrolment ratio (%) in Euro area and Gross enrolment ratio (%) in Austria?
Offer a very short reply. 3.21. In the year 1982, what is the difference between the Gross enrolment ratio (%) in Euro area and Gross enrolment ratio (%) in Samoa?
Ensure brevity in your answer.  6.79. In the year 1982, what is the difference between the Gross enrolment ratio (%) of Latin America(developing only) and Gross enrolment ratio (%) of Austria?
Keep it short and to the point. 17.88. In the year 1982, what is the difference between the Gross enrolment ratio (%) of Latin America(developing only) and Gross enrolment ratio (%) of Samoa?
Give a very brief answer. 21.46. In the year 1982, what is the difference between the Gross enrolment ratio (%) in Austria and Gross enrolment ratio (%) in Samoa?
Make the answer very short. 3.58. What is the ratio of the Gross enrolment ratio (%) of Latin America(developing only) in 1975 to that in 1976?
Ensure brevity in your answer.  1. What is the ratio of the Gross enrolment ratio (%) in Austria in 1975 to that in 1976?
Provide a short and direct response. 1. What is the ratio of the Gross enrolment ratio (%) of Samoa in 1975 to that in 1976?
Keep it short and to the point. 0.98. What is the ratio of the Gross enrolment ratio (%) in Latin America(developing only) in 1975 to that in 1977?
Ensure brevity in your answer.  0.98. What is the ratio of the Gross enrolment ratio (%) of Austria in 1975 to that in 1977?
Your response must be concise. 0.99. What is the ratio of the Gross enrolment ratio (%) of Samoa in 1975 to that in 1977?
Provide a succinct answer. 0.96. What is the ratio of the Gross enrolment ratio (%) of Euro area in 1975 to that in 1978?
Ensure brevity in your answer.  1.01. What is the ratio of the Gross enrolment ratio (%) of Latin America(developing only) in 1975 to that in 1978?
Offer a terse response. 0.96. What is the ratio of the Gross enrolment ratio (%) of Austria in 1975 to that in 1978?
Keep it short and to the point. 1.01. What is the ratio of the Gross enrolment ratio (%) of Samoa in 1975 to that in 1978?
Offer a very short reply. 0.95. What is the ratio of the Gross enrolment ratio (%) in Euro area in 1975 to that in 1979?
Your answer should be compact. 1.01. What is the ratio of the Gross enrolment ratio (%) of Latin America(developing only) in 1975 to that in 1979?
Offer a very short reply. 0.93. What is the ratio of the Gross enrolment ratio (%) in Austria in 1975 to that in 1979?
Your answer should be very brief. 1.01. What is the ratio of the Gross enrolment ratio (%) in Samoa in 1975 to that in 1979?
Provide a short and direct response. 0.93. What is the ratio of the Gross enrolment ratio (%) of Euro area in 1975 to that in 1980?
Your response must be concise. 1.02. What is the ratio of the Gross enrolment ratio (%) of Latin America(developing only) in 1975 to that in 1980?
Provide a succinct answer. 0.93. What is the ratio of the Gross enrolment ratio (%) of Austria in 1975 to that in 1980?
Make the answer very short. 1.01. What is the ratio of the Gross enrolment ratio (%) of Samoa in 1975 to that in 1980?
Offer a terse response. 0.94. What is the ratio of the Gross enrolment ratio (%) in Euro area in 1975 to that in 1981?
Keep it short and to the point. 1.02. What is the ratio of the Gross enrolment ratio (%) of Latin America(developing only) in 1975 to that in 1981?
Your answer should be very brief. 0.93. What is the ratio of the Gross enrolment ratio (%) of Austria in 1975 to that in 1981?
Make the answer very short. 1.01. What is the ratio of the Gross enrolment ratio (%) of Samoa in 1975 to that in 1981?
Your answer should be very brief. 0.95. What is the ratio of the Gross enrolment ratio (%) of Euro area in 1975 to that in 1982?
Keep it short and to the point. 1.02. What is the ratio of the Gross enrolment ratio (%) in Latin America(developing only) in 1975 to that in 1982?
Provide a succinct answer. 0.93. What is the ratio of the Gross enrolment ratio (%) in Samoa in 1975 to that in 1982?
Your answer should be compact. 0.97. What is the ratio of the Gross enrolment ratio (%) in Euro area in 1976 to that in 1977?
Offer a terse response. 1.01. What is the ratio of the Gross enrolment ratio (%) of Latin America(developing only) in 1976 to that in 1977?
Your answer should be compact. 0.98. What is the ratio of the Gross enrolment ratio (%) of Samoa in 1976 to that in 1977?
Your answer should be compact. 0.98. What is the ratio of the Gross enrolment ratio (%) in Euro area in 1976 to that in 1978?
Your answer should be compact. 1.01. What is the ratio of the Gross enrolment ratio (%) in Latin America(developing only) in 1976 to that in 1978?
Provide a succinct answer. 0.96. What is the ratio of the Gross enrolment ratio (%) of Austria in 1976 to that in 1978?
Offer a very short reply. 1.01. What is the ratio of the Gross enrolment ratio (%) in Samoa in 1976 to that in 1978?
Your answer should be compact. 0.97. What is the ratio of the Gross enrolment ratio (%) in Euro area in 1976 to that in 1979?
Provide a short and direct response. 1.01. What is the ratio of the Gross enrolment ratio (%) of Latin America(developing only) in 1976 to that in 1979?
Your answer should be compact. 0.93. What is the ratio of the Gross enrolment ratio (%) of Austria in 1976 to that in 1979?
Give a very brief answer. 1.01. What is the ratio of the Gross enrolment ratio (%) in Samoa in 1976 to that in 1979?
Offer a terse response. 0.94. What is the ratio of the Gross enrolment ratio (%) in Euro area in 1976 to that in 1980?
Make the answer very short. 1.01. What is the ratio of the Gross enrolment ratio (%) of Latin America(developing only) in 1976 to that in 1980?
Your response must be concise. 0.93. What is the ratio of the Gross enrolment ratio (%) in Austria in 1976 to that in 1980?
Your answer should be very brief. 1.01. What is the ratio of the Gross enrolment ratio (%) in Samoa in 1976 to that in 1980?
Offer a very short reply. 0.96. What is the ratio of the Gross enrolment ratio (%) in Euro area in 1976 to that in 1981?
Keep it short and to the point. 1.02. What is the ratio of the Gross enrolment ratio (%) in Latin America(developing only) in 1976 to that in 1981?
Your answer should be compact. 0.93. What is the ratio of the Gross enrolment ratio (%) in Austria in 1976 to that in 1981?
Your answer should be very brief. 1.01. What is the ratio of the Gross enrolment ratio (%) in Samoa in 1976 to that in 1981?
Make the answer very short. 0.97. What is the ratio of the Gross enrolment ratio (%) in Euro area in 1976 to that in 1982?
Offer a very short reply. 1.02. What is the ratio of the Gross enrolment ratio (%) of Latin America(developing only) in 1976 to that in 1982?
Your answer should be very brief. 0.92. What is the ratio of the Gross enrolment ratio (%) in Samoa in 1976 to that in 1982?
Make the answer very short. 0.98. What is the ratio of the Gross enrolment ratio (%) in Euro area in 1977 to that in 1978?
Make the answer very short. 1. What is the ratio of the Gross enrolment ratio (%) of Latin America(developing only) in 1977 to that in 1978?
Offer a terse response. 0.98. What is the ratio of the Gross enrolment ratio (%) in Austria in 1977 to that in 1978?
Your response must be concise. 1.02. What is the ratio of the Gross enrolment ratio (%) in Euro area in 1977 to that in 1979?
Make the answer very short. 1.01. What is the ratio of the Gross enrolment ratio (%) of Latin America(developing only) in 1977 to that in 1979?
Keep it short and to the point. 0.95. What is the ratio of the Gross enrolment ratio (%) of Austria in 1977 to that in 1979?
Offer a terse response. 1.02. What is the ratio of the Gross enrolment ratio (%) in Samoa in 1977 to that in 1979?
Offer a very short reply. 0.97. What is the ratio of the Gross enrolment ratio (%) in Euro area in 1977 to that in 1980?
Provide a short and direct response. 1.01. What is the ratio of the Gross enrolment ratio (%) in Latin America(developing only) in 1977 to that in 1980?
Make the answer very short. 0.95. What is the ratio of the Gross enrolment ratio (%) of Austria in 1977 to that in 1980?
Keep it short and to the point. 1.02. What is the ratio of the Gross enrolment ratio (%) of Samoa in 1977 to that in 1980?
Offer a very short reply. 0.98. What is the ratio of the Gross enrolment ratio (%) of Euro area in 1977 to that in 1981?
Provide a short and direct response. 1.01. What is the ratio of the Gross enrolment ratio (%) in Latin America(developing only) in 1977 to that in 1981?
Offer a terse response. 0.95. What is the ratio of the Gross enrolment ratio (%) in Austria in 1977 to that in 1981?
Give a very brief answer. 1.02. What is the ratio of the Gross enrolment ratio (%) of Euro area in 1977 to that in 1982?
Make the answer very short. 1.02. What is the ratio of the Gross enrolment ratio (%) in Latin America(developing only) in 1977 to that in 1982?
Your answer should be compact. 0.95. What is the ratio of the Gross enrolment ratio (%) in Austria in 1977 to that in 1982?
Give a very brief answer. 1.01. What is the ratio of the Gross enrolment ratio (%) in Samoa in 1977 to that in 1982?
Your answer should be very brief. 1.01. What is the ratio of the Gross enrolment ratio (%) in Samoa in 1978 to that in 1979?
Offer a very short reply. 0.98. What is the ratio of the Gross enrolment ratio (%) of Euro area in 1978 to that in 1980?
Ensure brevity in your answer.  1.01. What is the ratio of the Gross enrolment ratio (%) of Latin America(developing only) in 1978 to that in 1980?
Give a very brief answer. 0.96. What is the ratio of the Gross enrolment ratio (%) of Samoa in 1978 to that in 1980?
Your answer should be very brief. 0.99. What is the ratio of the Gross enrolment ratio (%) of Euro area in 1978 to that in 1981?
Offer a terse response. 1.01. What is the ratio of the Gross enrolment ratio (%) in Latin America(developing only) in 1978 to that in 1981?
Provide a short and direct response. 0.97. What is the ratio of the Gross enrolment ratio (%) of Samoa in 1978 to that in 1981?
Keep it short and to the point. 1.01. What is the ratio of the Gross enrolment ratio (%) of Euro area in 1978 to that in 1982?
Give a very brief answer. 1.01. What is the ratio of the Gross enrolment ratio (%) in Latin America(developing only) in 1978 to that in 1982?
Your answer should be very brief. 0.96. What is the ratio of the Gross enrolment ratio (%) of Samoa in 1978 to that in 1982?
Keep it short and to the point. 1.02. What is the ratio of the Gross enrolment ratio (%) in Euro area in 1979 to that in 1980?
Keep it short and to the point. 1. What is the ratio of the Gross enrolment ratio (%) of Samoa in 1979 to that in 1980?
Offer a terse response. 1.02. What is the ratio of the Gross enrolment ratio (%) of Latin America(developing only) in 1979 to that in 1981?
Offer a terse response. 1. What is the ratio of the Gross enrolment ratio (%) of Samoa in 1979 to that in 1981?
Make the answer very short. 1.03. What is the ratio of the Gross enrolment ratio (%) of Euro area in 1979 to that in 1982?
Your answer should be very brief. 1.01. What is the ratio of the Gross enrolment ratio (%) in Austria in 1979 to that in 1982?
Make the answer very short. 0.99. What is the ratio of the Gross enrolment ratio (%) in Samoa in 1979 to that in 1982?
Your answer should be very brief. 1.04. What is the ratio of the Gross enrolment ratio (%) of Samoa in 1980 to that in 1981?
Provide a short and direct response. 1.01. What is the ratio of the Gross enrolment ratio (%) of Austria in 1980 to that in 1982?
Offer a very short reply. 0.99. What is the ratio of the Gross enrolment ratio (%) of Samoa in 1980 to that in 1982?
Offer a terse response. 1.03. What is the ratio of the Gross enrolment ratio (%) in Austria in 1981 to that in 1982?
Your answer should be very brief. 0.99. What is the ratio of the Gross enrolment ratio (%) in Samoa in 1981 to that in 1982?
Keep it short and to the point. 1.01. What is the difference between the highest and the second highest Gross enrolment ratio (%) of Euro area?
Your answer should be compact. 0.1. What is the difference between the highest and the second highest Gross enrolment ratio (%) of Latin America(developing only)?
Give a very brief answer. 0.39. What is the difference between the highest and the second highest Gross enrolment ratio (%) of Austria?
Your answer should be compact. 0.76. What is the difference between the highest and the second highest Gross enrolment ratio (%) of Samoa?
Your response must be concise. 1.65. What is the difference between the highest and the lowest Gross enrolment ratio (%) of Euro area?
Your response must be concise. 2.22. What is the difference between the highest and the lowest Gross enrolment ratio (%) in Latin America(developing only)?
Give a very brief answer. 8.98. What is the difference between the highest and the lowest Gross enrolment ratio (%) of Austria?
Ensure brevity in your answer.  2.23. What is the difference between the highest and the lowest Gross enrolment ratio (%) of Samoa?
Your answer should be compact. 7.25. 